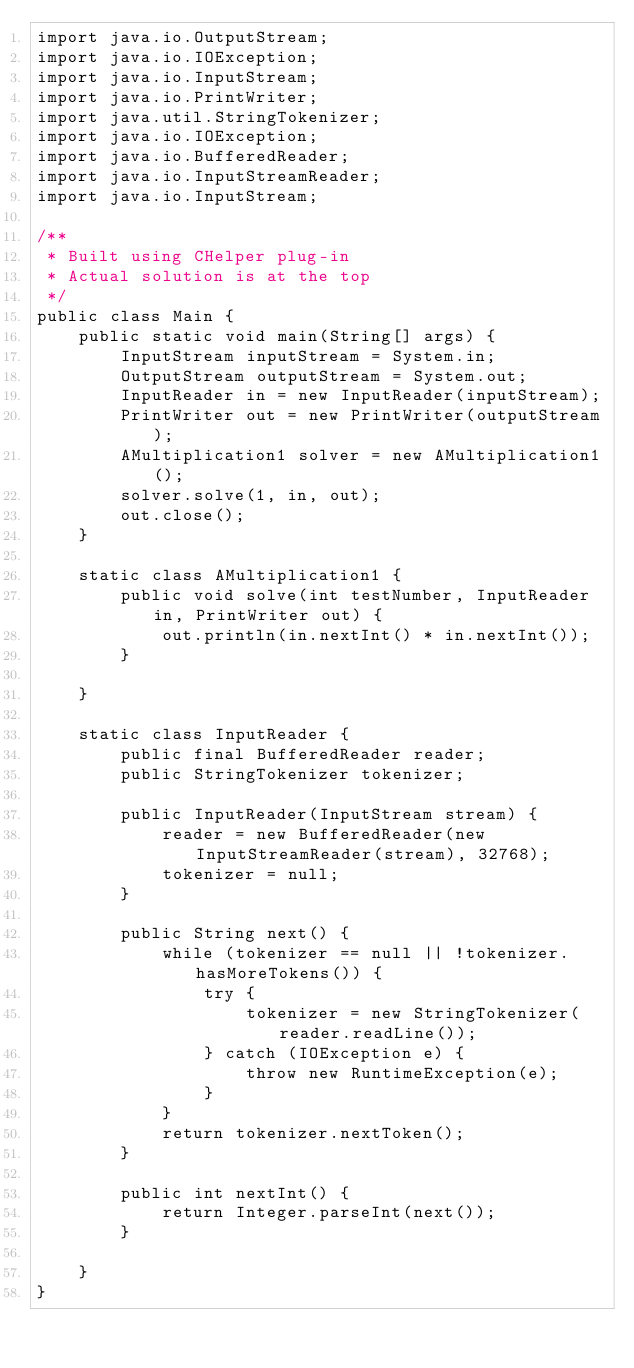Convert code to text. <code><loc_0><loc_0><loc_500><loc_500><_Java_>import java.io.OutputStream;
import java.io.IOException;
import java.io.InputStream;
import java.io.PrintWriter;
import java.util.StringTokenizer;
import java.io.IOException;
import java.io.BufferedReader;
import java.io.InputStreamReader;
import java.io.InputStream;

/**
 * Built using CHelper plug-in
 * Actual solution is at the top
 */
public class Main {
    public static void main(String[] args) {
        InputStream inputStream = System.in;
        OutputStream outputStream = System.out;
        InputReader in = new InputReader(inputStream);
        PrintWriter out = new PrintWriter(outputStream);
        AMultiplication1 solver = new AMultiplication1();
        solver.solve(1, in, out);
        out.close();
    }

    static class AMultiplication1 {
        public void solve(int testNumber, InputReader in, PrintWriter out) {
            out.println(in.nextInt() * in.nextInt());
        }

    }

    static class InputReader {
        public final BufferedReader reader;
        public StringTokenizer tokenizer;

        public InputReader(InputStream stream) {
            reader = new BufferedReader(new InputStreamReader(stream), 32768);
            tokenizer = null;
        }

        public String next() {
            while (tokenizer == null || !tokenizer.hasMoreTokens()) {
                try {
                    tokenizer = new StringTokenizer(reader.readLine());
                } catch (IOException e) {
                    throw new RuntimeException(e);
                }
            }
            return tokenizer.nextToken();
        }

        public int nextInt() {
            return Integer.parseInt(next());
        }

    }
}

</code> 